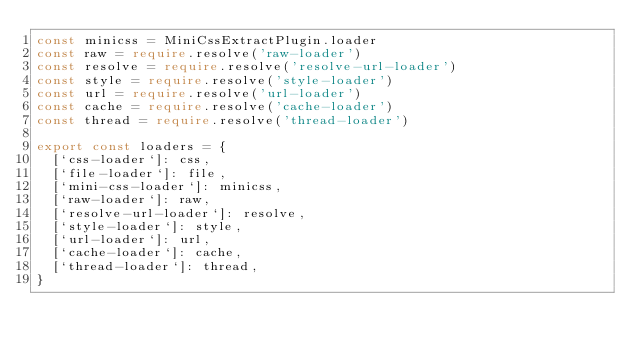<code> <loc_0><loc_0><loc_500><loc_500><_TypeScript_>const minicss = MiniCssExtractPlugin.loader
const raw = require.resolve('raw-loader')
const resolve = require.resolve('resolve-url-loader')
const style = require.resolve('style-loader')
const url = require.resolve('url-loader')
const cache = require.resolve('cache-loader')
const thread = require.resolve('thread-loader')

export const loaders = {
  [`css-loader`]: css,
  [`file-loader`]: file,
  [`mini-css-loader`]: minicss,
  [`raw-loader`]: raw,
  [`resolve-url-loader`]: resolve,
  [`style-loader`]: style,
  [`url-loader`]: url,
  [`cache-loader`]: cache,
  [`thread-loader`]: thread,
}
</code> 